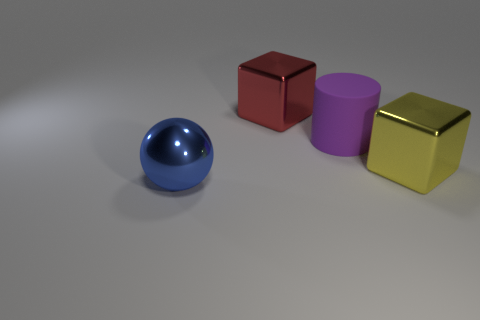Is there any other thing that has the same material as the large cylinder?
Your answer should be compact. No. Is the material of the large blue object the same as the large cube in front of the big purple matte object?
Ensure brevity in your answer.  Yes. What is the large purple thing made of?
Your answer should be compact. Rubber. What shape is the big blue thing that is made of the same material as the red block?
Provide a succinct answer. Sphere. What number of other objects are the same shape as the big purple thing?
Your answer should be compact. 0. How many big blue metal spheres are to the left of the yellow metal cube?
Offer a terse response. 1. There is a block in front of the big red metal block; is its size the same as the block to the left of the big rubber thing?
Offer a terse response. Yes. There is a big thing in front of the cube that is in front of the big red object that is on the left side of the yellow cube; what is its material?
Offer a very short reply. Metal. There is a sphere; is its size the same as the shiny cube that is on the left side of the big yellow shiny thing?
Your answer should be very brief. Yes. There is a object that is behind the large yellow block and left of the large purple rubber object; how big is it?
Make the answer very short. Large. 